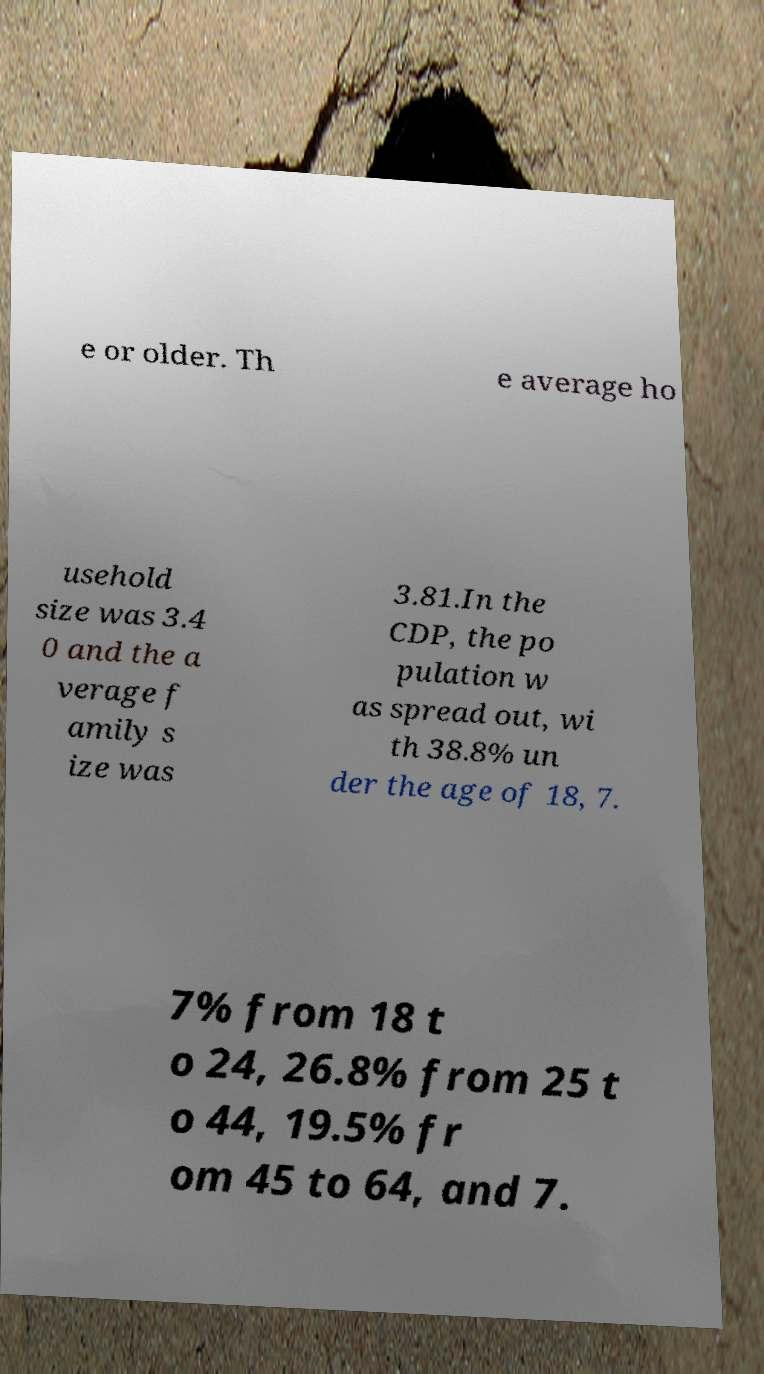Can you accurately transcribe the text from the provided image for me? e or older. Th e average ho usehold size was 3.4 0 and the a verage f amily s ize was 3.81.In the CDP, the po pulation w as spread out, wi th 38.8% un der the age of 18, 7. 7% from 18 t o 24, 26.8% from 25 t o 44, 19.5% fr om 45 to 64, and 7. 